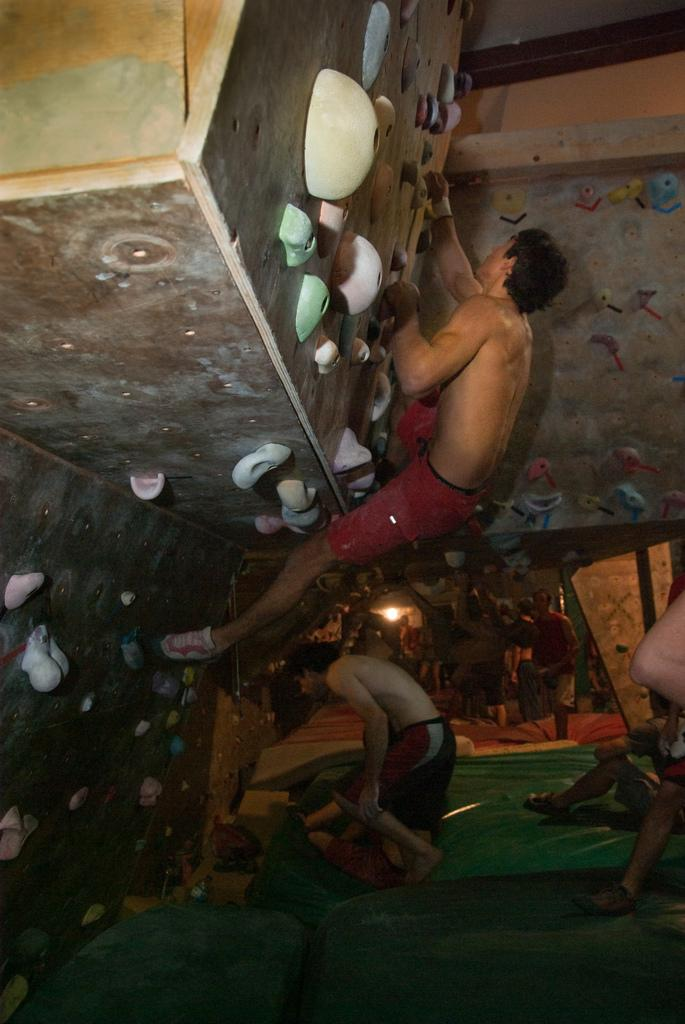What can be seen on the right side of the image? There are people on the right side of the image. What is located on the left side of the image? There is an indoor rock climbing wall on the left side of the image. What activity is being performed by a person in the image? A person is climbing the rock climbing wall. Where is the baby sitting in the image? There is no baby present in the image. What type of tree can be seen on the rock climbing wall? There are no trees present in the image, as it features an indoor rock climbing wall. 